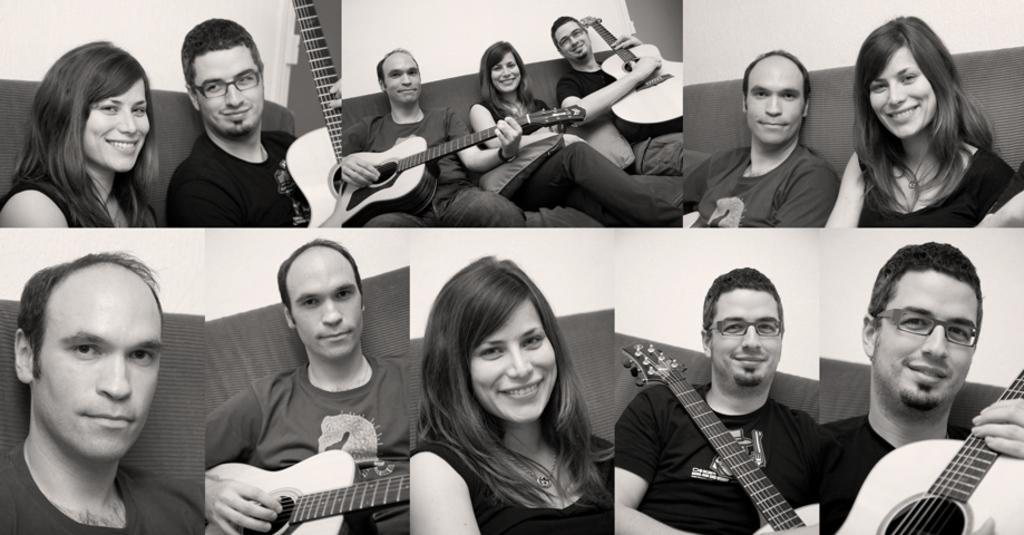Describe this image in one or two sentences. This picture shows the college of similar pictures and we see a woman and two men in the picture where to men holding guitar in their hand 